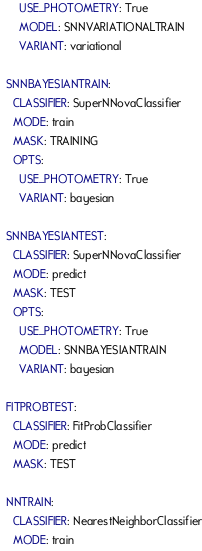Convert code to text. <code><loc_0><loc_0><loc_500><loc_500><_YAML_>      USE_PHOTOMETRY: True
      MODEL: SNNVARIATIONALTRAIN
      VARIANT: variational

  SNNBAYESIANTRAIN:
    CLASSIFIER: SuperNNovaClassifier
    MODE: train
    MASK: TRAINING
    OPTS:
      USE_PHOTOMETRY: True
      VARIANT: bayesian

  SNNBAYESIANTEST:
    CLASSIFIER: SuperNNovaClassifier
    MODE: predict
    MASK: TEST
    OPTS:
      USE_PHOTOMETRY: True
      MODEL: SNNBAYESIANTRAIN
      VARIANT: bayesian

  FITPROBTEST:
    CLASSIFIER: FitProbClassifier
    MODE: predict
    MASK: TEST

  NNTRAIN:
    CLASSIFIER: NearestNeighborClassifier
    MODE: train</code> 